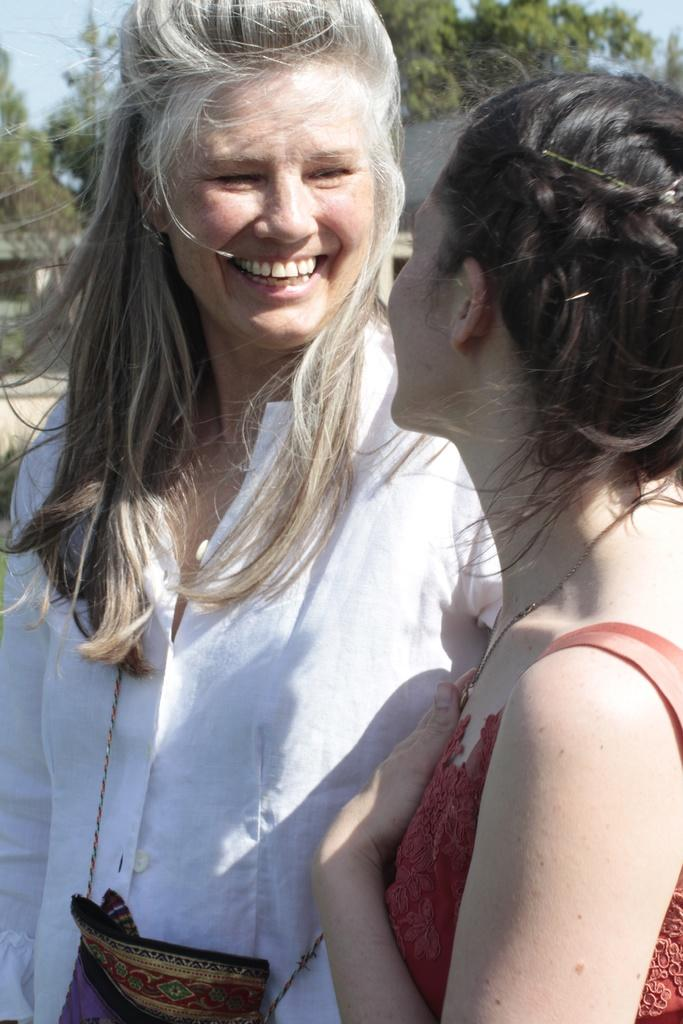What is the appearance of the woman on the right side of the image? There is a beautiful woman on the right side of the image. What is the woman on the right side wearing? The beautiful woman is wearing an orange dress. What is the appearance of the woman in the middle of the image? There is a woman standing in the middle of the image, and she is wearing a white shirt. What can be seen in the background of the image? There are green trees visible in the background of the image. What type of note is the woman on the right side holding in the image? There is no note present in the image; the woman on the right side is wearing an orange dress and standing next to a woman in the middle wearing a white shirt. 